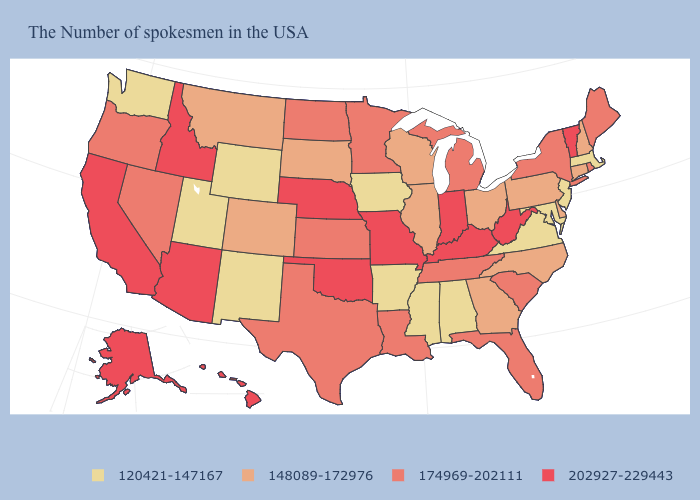Among the states that border West Virginia , which have the lowest value?
Keep it brief. Maryland, Virginia. Which states hav the highest value in the West?
Write a very short answer. Arizona, Idaho, California, Alaska, Hawaii. Does the first symbol in the legend represent the smallest category?
Keep it brief. Yes. Name the states that have a value in the range 174969-202111?
Keep it brief. Maine, Rhode Island, New York, South Carolina, Florida, Michigan, Tennessee, Louisiana, Minnesota, Kansas, Texas, North Dakota, Nevada, Oregon. What is the value of Delaware?
Quick response, please. 148089-172976. Does South Carolina have the lowest value in the South?
Short answer required. No. What is the value of North Dakota?
Short answer required. 174969-202111. Does New Hampshire have the lowest value in the Northeast?
Concise answer only. No. Which states have the highest value in the USA?
Keep it brief. Vermont, West Virginia, Kentucky, Indiana, Missouri, Nebraska, Oklahoma, Arizona, Idaho, California, Alaska, Hawaii. Name the states that have a value in the range 120421-147167?
Short answer required. Massachusetts, New Jersey, Maryland, Virginia, Alabama, Mississippi, Arkansas, Iowa, Wyoming, New Mexico, Utah, Washington. Does Nebraska have a higher value than Mississippi?
Quick response, please. Yes. Name the states that have a value in the range 148089-172976?
Give a very brief answer. New Hampshire, Connecticut, Delaware, Pennsylvania, North Carolina, Ohio, Georgia, Wisconsin, Illinois, South Dakota, Colorado, Montana. Does the map have missing data?
Short answer required. No. What is the value of Arkansas?
Keep it brief. 120421-147167. Name the states that have a value in the range 148089-172976?
Keep it brief. New Hampshire, Connecticut, Delaware, Pennsylvania, North Carolina, Ohio, Georgia, Wisconsin, Illinois, South Dakota, Colorado, Montana. 